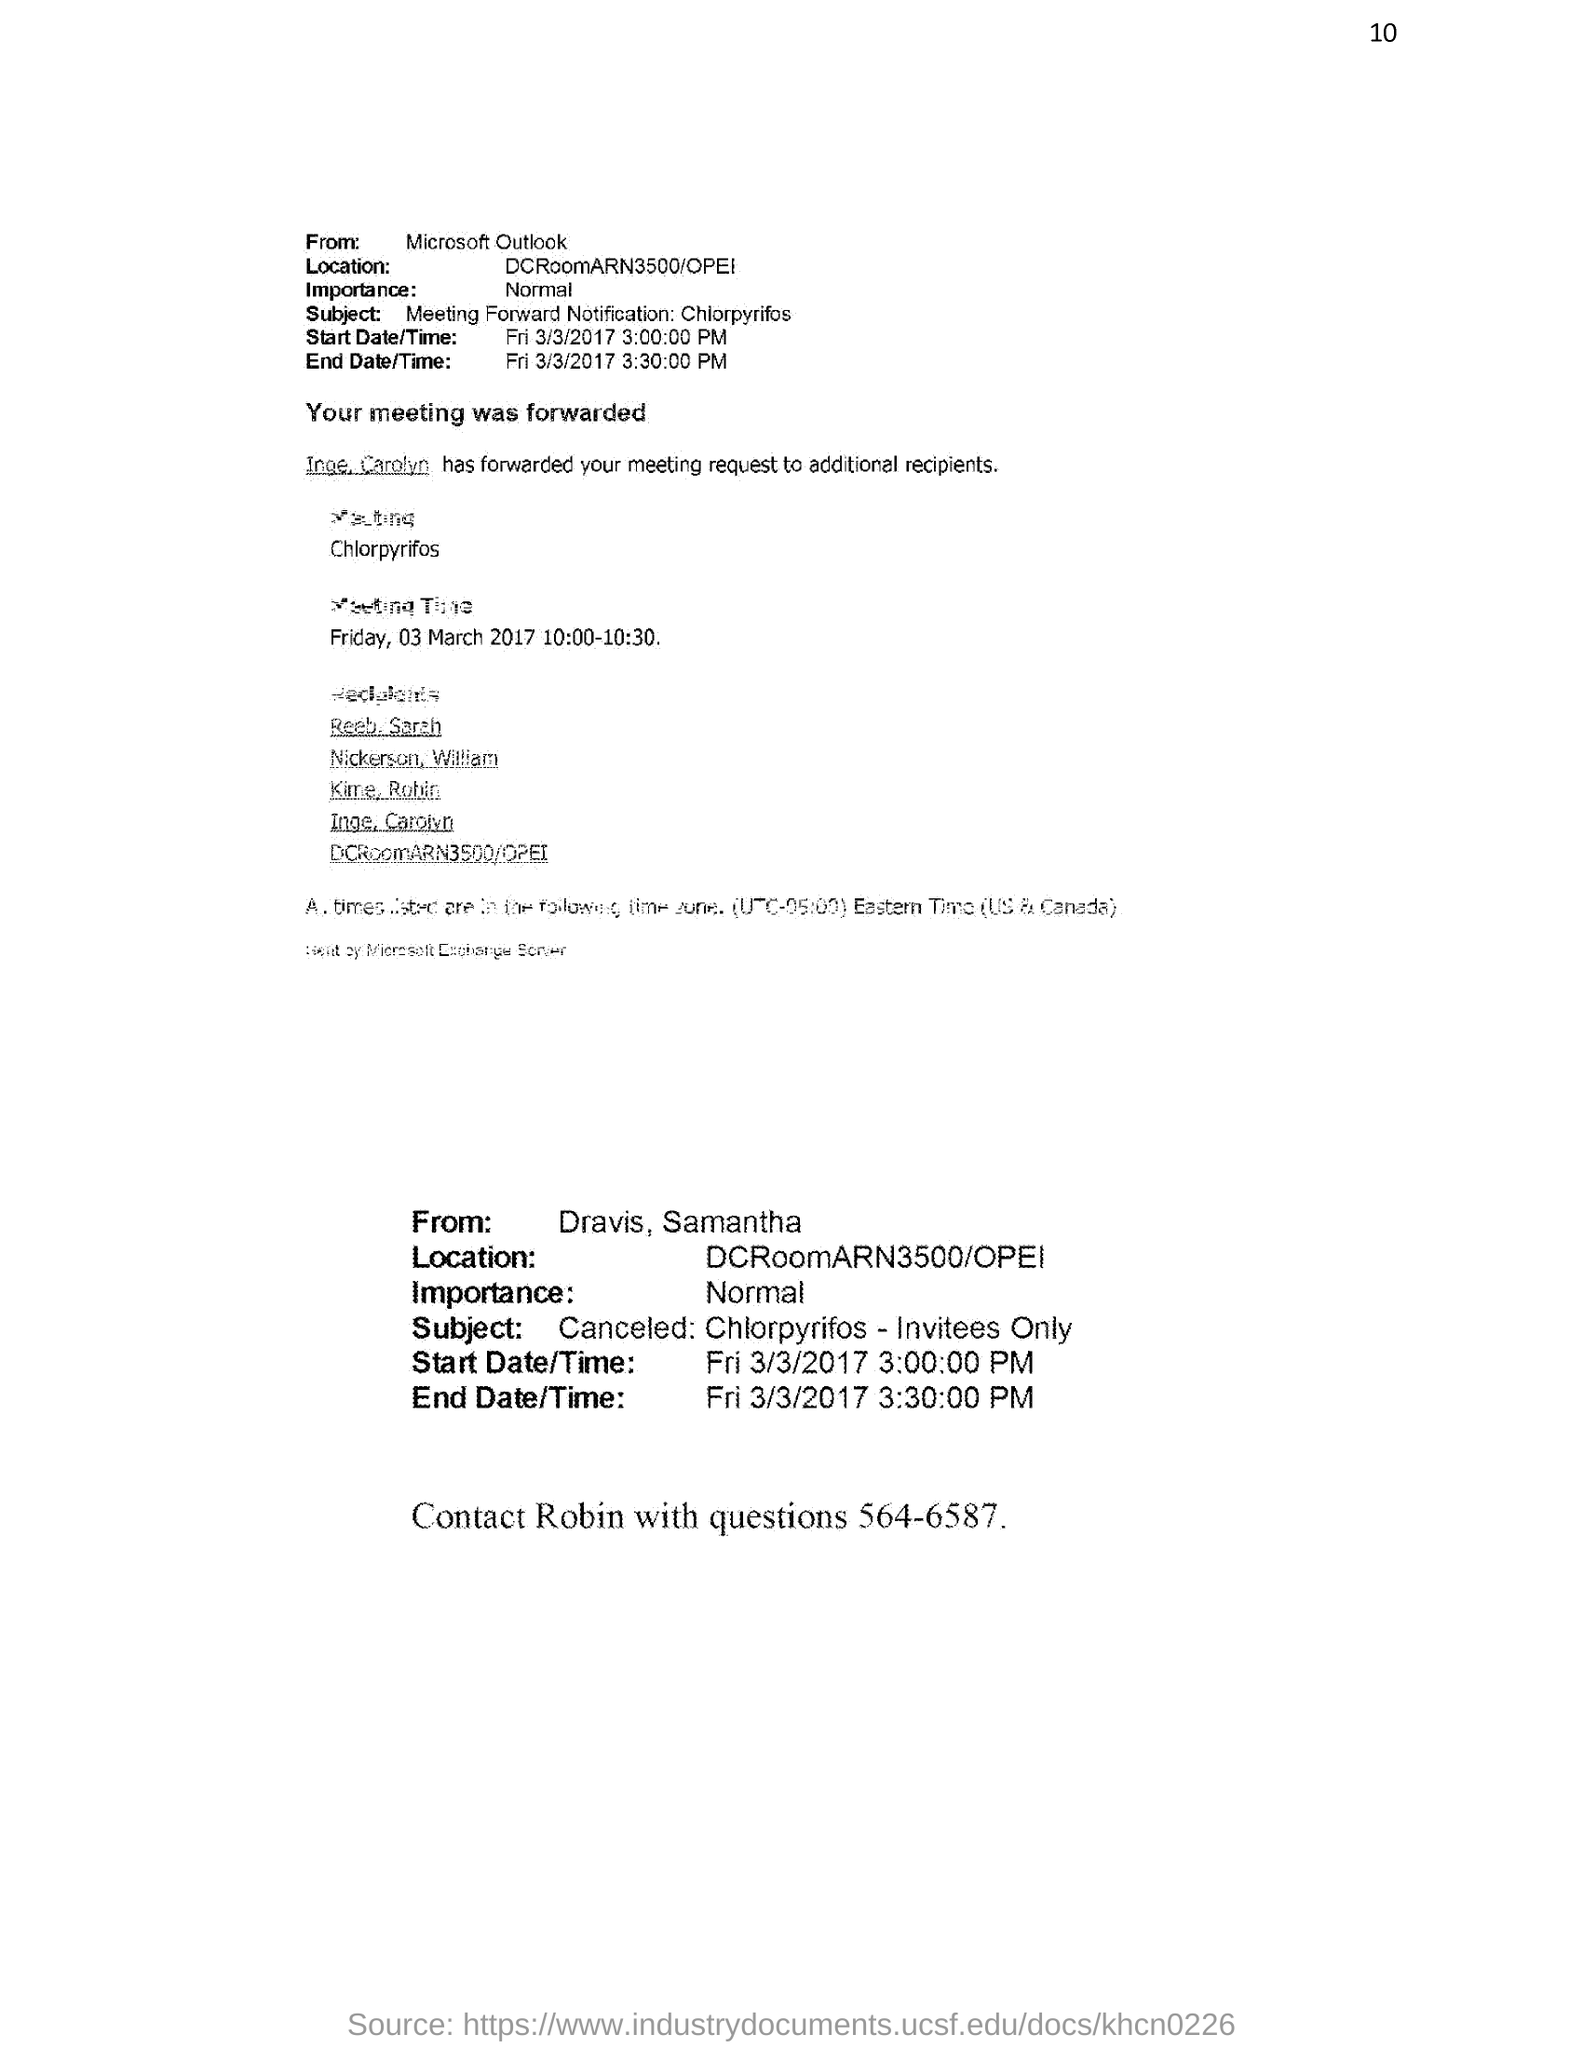What is the contact no of Robin?
Your answer should be compact. 564-6587. What is the importance level of the email?
Provide a succinct answer. Normal. What is start time of the meeting?
Offer a terse response. Fri 3/3/2017 3:00:00 PM. What is the end time of the meeting?
Make the answer very short. 3:30:00 PM. 